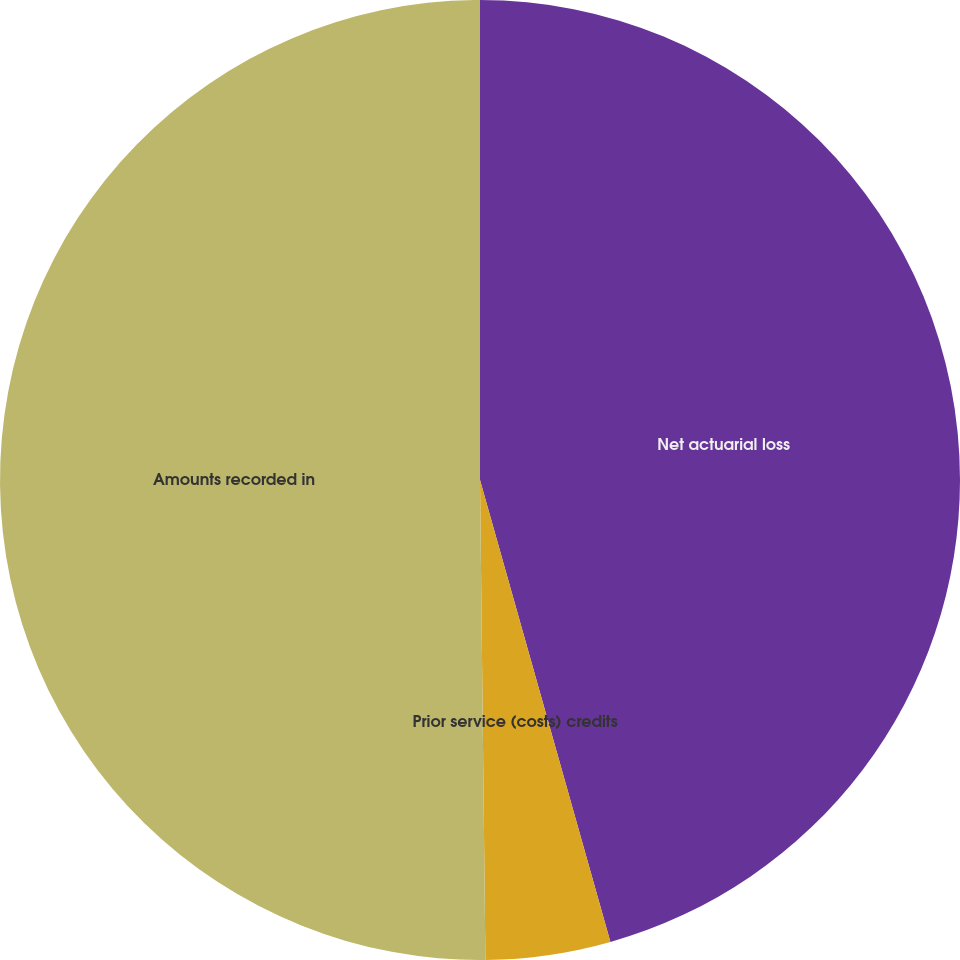Convert chart. <chart><loc_0><loc_0><loc_500><loc_500><pie_chart><fcel>Net actuarial loss<fcel>Prior service (costs) credits<fcel>Amounts recorded in<nl><fcel>45.62%<fcel>4.2%<fcel>50.18%<nl></chart> 